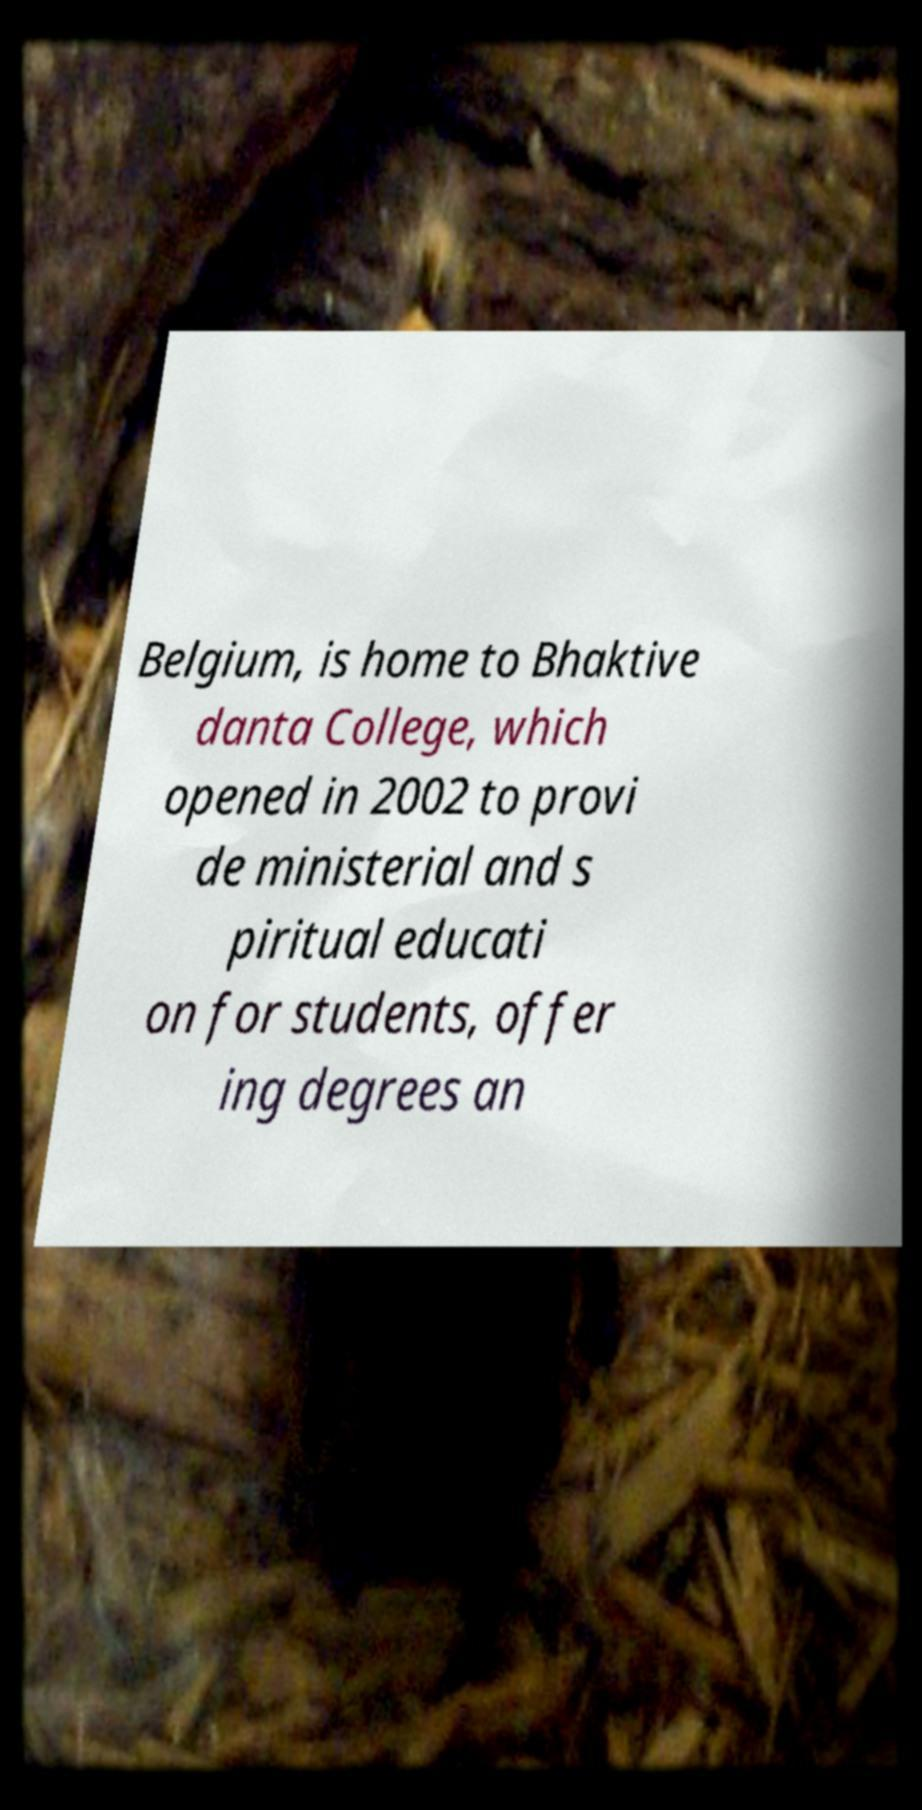I need the written content from this picture converted into text. Can you do that? Belgium, is home to Bhaktive danta College, which opened in 2002 to provi de ministerial and s piritual educati on for students, offer ing degrees an 